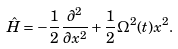Convert formula to latex. <formula><loc_0><loc_0><loc_500><loc_500>\hat { H } = - \frac { 1 } { 2 } \frac { \partial ^ { 2 } } { \partial x ^ { 2 } } + \frac { 1 } { 2 } \Omega ^ { 2 } ( t ) x ^ { 2 } .</formula> 